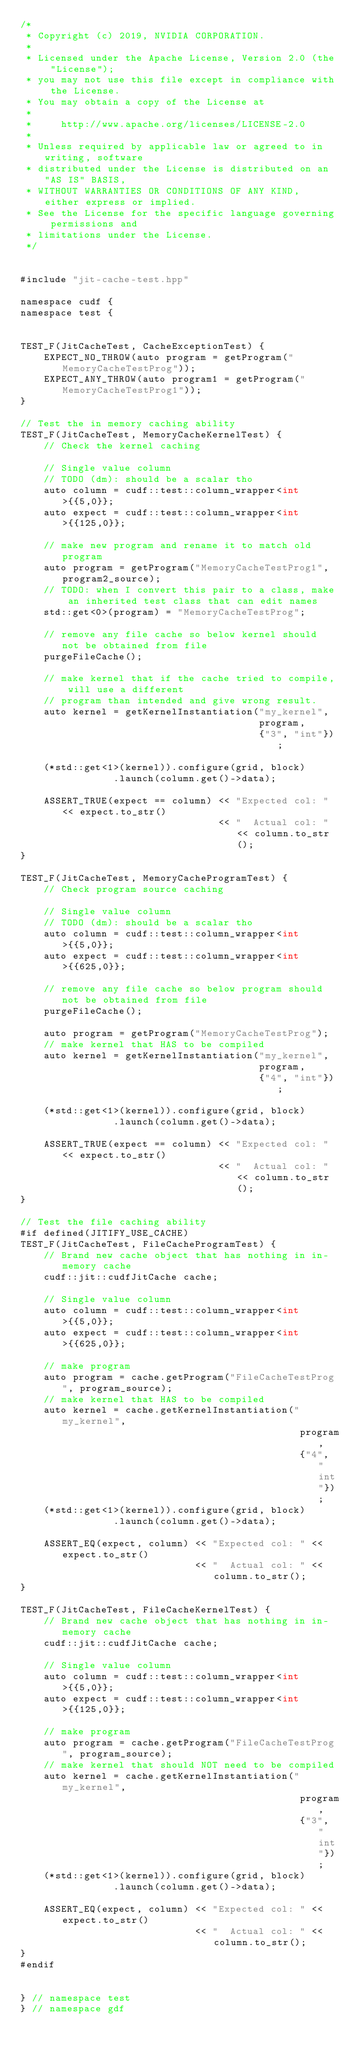Convert code to text. <code><loc_0><loc_0><loc_500><loc_500><_Cuda_>/*
 * Copyright (c) 2019, NVIDIA CORPORATION.
 *
 * Licensed under the Apache License, Version 2.0 (the "License");
 * you may not use this file except in compliance with the License.
 * You may obtain a copy of the License at
 *
 *     http://www.apache.org/licenses/LICENSE-2.0
 *
 * Unless required by applicable law or agreed to in writing, software
 * distributed under the License is distributed on an "AS IS" BASIS,
 * WITHOUT WARRANTIES OR CONDITIONS OF ANY KIND, either express or implied.
 * See the License for the specific language governing permissions and
 * limitations under the License.
 */


#include "jit-cache-test.hpp"

namespace cudf {
namespace test {


TEST_F(JitCacheTest, CacheExceptionTest) {
    EXPECT_NO_THROW(auto program = getProgram("MemoryCacheTestProg"));
    EXPECT_ANY_THROW(auto program1 = getProgram("MemoryCacheTestProg1"));
}

// Test the in memory caching ability
TEST_F(JitCacheTest, MemoryCacheKernelTest) {
    // Check the kernel caching

    // Single value column
    // TODO (dm): should be a scalar tho
    auto column = cudf::test::column_wrapper<int>{{5,0}};
    auto expect = cudf::test::column_wrapper<int>{{125,0}};

    // make new program and rename it to match old program
    auto program = getProgram("MemoryCacheTestProg1", program2_source);
    // TODO: when I convert this pair to a class, make an inherited test class that can edit names
    std::get<0>(program) = "MemoryCacheTestProg";

    // remove any file cache so below kernel should not be obtained from file
    purgeFileCache();

    // make kernel that if the cache tried to compile, will use a different
    // program than intended and give wrong result. 
    auto kernel = getKernelInstantiation("my_kernel",
                                         program,
                                         {"3", "int"});

    (*std::get<1>(kernel)).configure(grid, block)
                .launch(column.get()->data);

    ASSERT_TRUE(expect == column) << "Expected col: " << expect.to_str()
                                  << "  Actual col: " << column.to_str();
}

TEST_F(JitCacheTest, MemoryCacheProgramTest) {
    // Check program source caching

    // Single value column
    // TODO (dm): should be a scalar tho
    auto column = cudf::test::column_wrapper<int>{{5,0}};
    auto expect = cudf::test::column_wrapper<int>{{625,0}};

    // remove any file cache so below program should not be obtained from file
    purgeFileCache();

    auto program = getProgram("MemoryCacheTestProg");
    // make kernel that HAS to be compiled
    auto kernel = getKernelInstantiation("my_kernel",
                                         program,
                                         {"4", "int"});

    (*std::get<1>(kernel)).configure(grid, block)
                .launch(column.get()->data);

    ASSERT_TRUE(expect == column) << "Expected col: " << expect.to_str()
                                  << "  Actual col: " << column.to_str();
}

// Test the file caching ability
#if defined(JITIFY_USE_CACHE)
TEST_F(JitCacheTest, FileCacheProgramTest) {
    // Brand new cache object that has nothing in in-memory cache
    cudf::jit::cudfJitCache cache;

    // Single value column
    auto column = cudf::test::column_wrapper<int>{{5,0}};
    auto expect = cudf::test::column_wrapper<int>{{625,0}};

    // make program
    auto program = cache.getProgram("FileCacheTestProg", program_source);
    // make kernel that HAS to be compiled
    auto kernel = cache.getKernelInstantiation("my_kernel",
                                                program,
                                                {"4", "int"});
    (*std::get<1>(kernel)).configure(grid, block)
                .launch(column.get()->data);

    ASSERT_EQ(expect, column) << "Expected col: " << expect.to_str()
                              << "  Actual col: " << column.to_str();
}

TEST_F(JitCacheTest, FileCacheKernelTest) {
    // Brand new cache object that has nothing in in-memory cache
    cudf::jit::cudfJitCache cache;

    // Single value column
    auto column = cudf::test::column_wrapper<int>{{5,0}};
    auto expect = cudf::test::column_wrapper<int>{{125,0}};

    // make program
    auto program = cache.getProgram("FileCacheTestProg", program_source);
    // make kernel that should NOT need to be compiled
    auto kernel = cache.getKernelInstantiation("my_kernel",
                                                program,
                                                {"3", "int"});
    (*std::get<1>(kernel)).configure(grid, block)
                .launch(column.get()->data);

    ASSERT_EQ(expect, column) << "Expected col: " << expect.to_str()
                              << "  Actual col: " << column.to_str();
}
#endif


} // namespace test
} // namespace gdf
</code> 